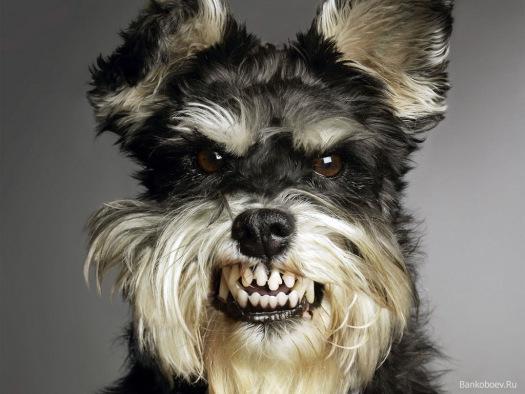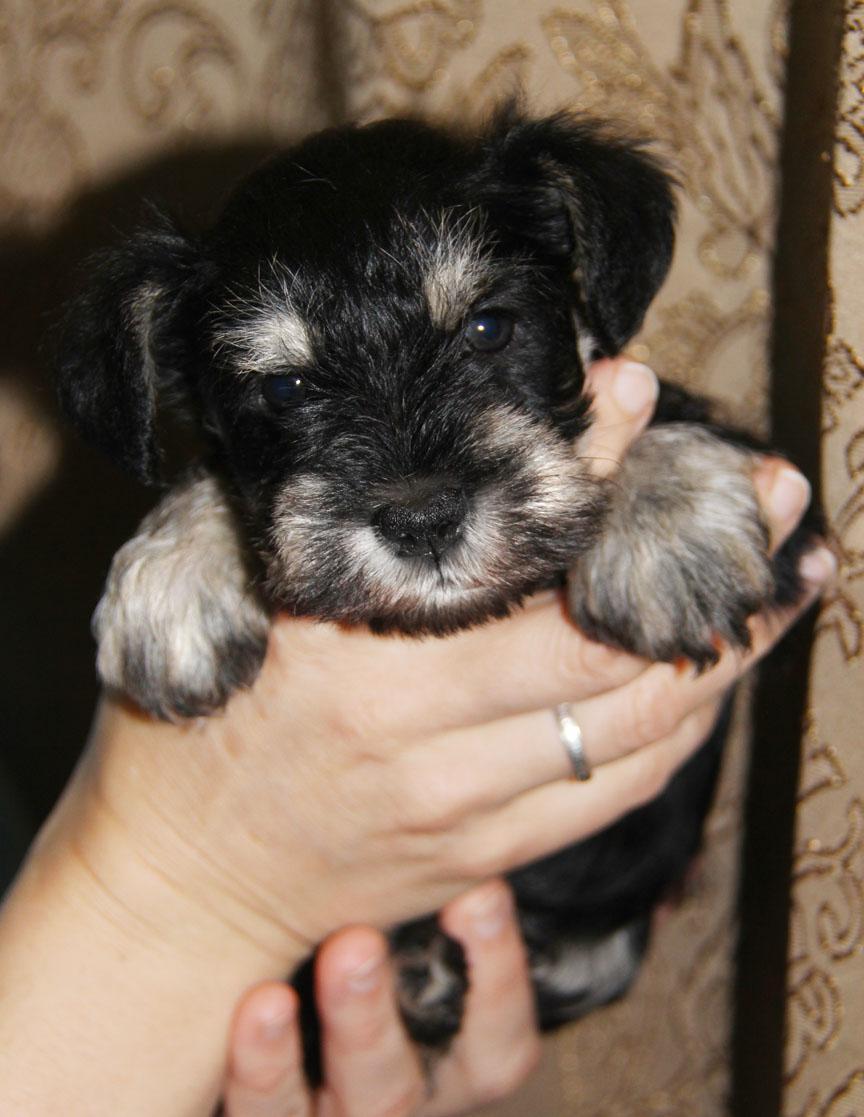The first image is the image on the left, the second image is the image on the right. For the images shown, is this caption "Part of a human limb is visible in an image containing one small schnauzer dog." true? Answer yes or no. Yes. The first image is the image on the left, the second image is the image on the right. Analyze the images presented: Is the assertion "One of the dogs is next to a human, and at least one of the dogs is close to a couch." valid? Answer yes or no. No. 